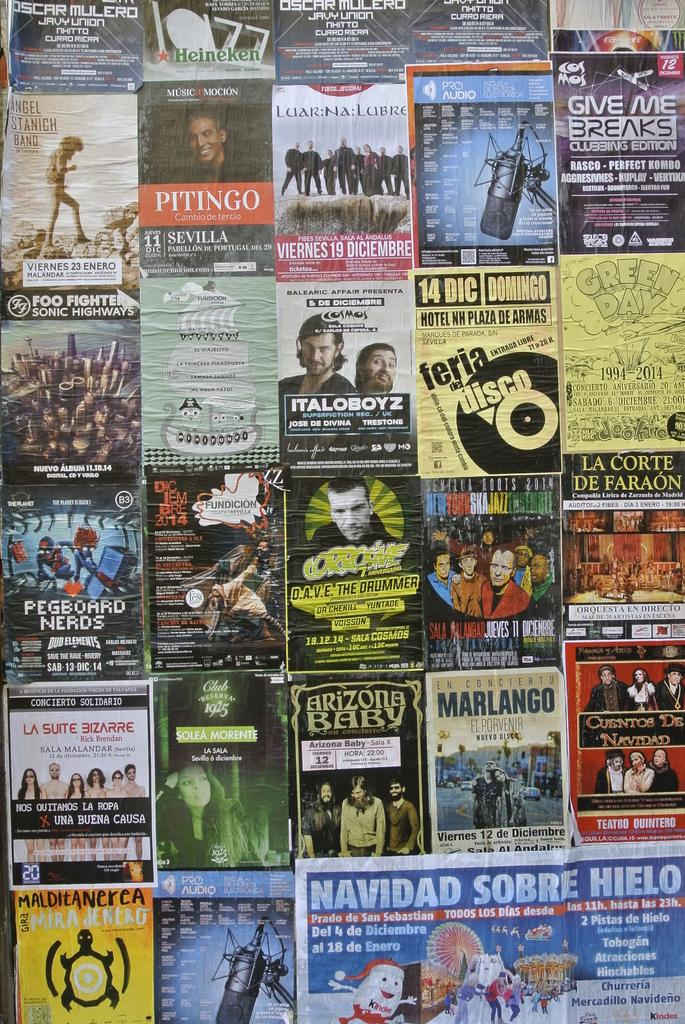<image>
Offer a succinct explanation of the picture presented. A display of music posters including one for Foo Fighters. 